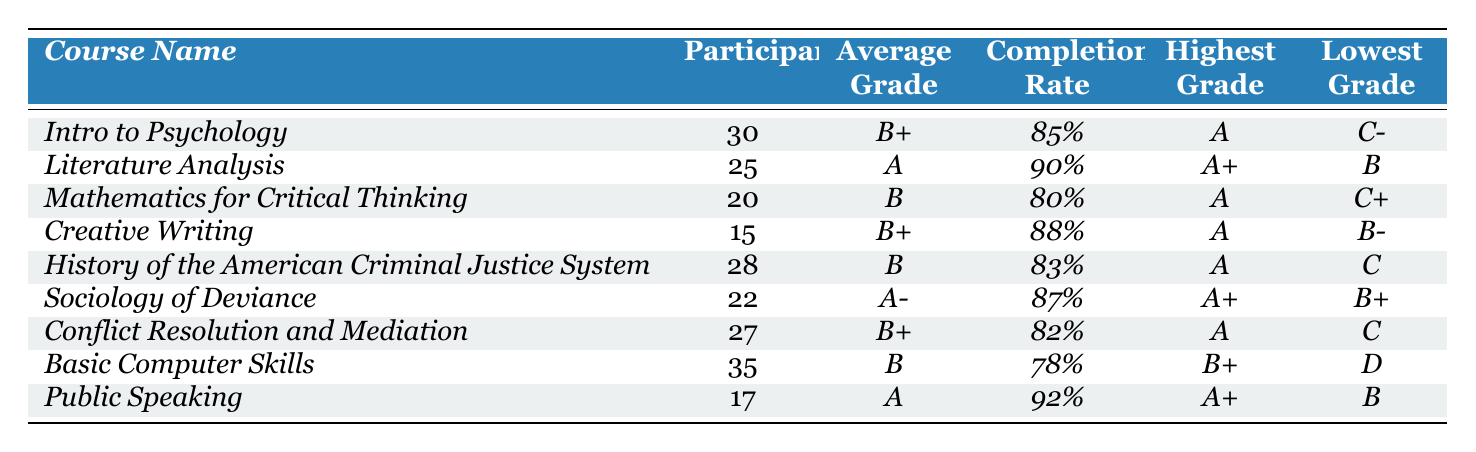What is the highest grade received in the _Literature Analysis_ course? The highest grade for the _Literature Analysis_ course is indicated in the table as _A+_.
Answer: _A+_ How many participants were there in total for all courses combined? To find the total number of participants, I sum the participants from each course: 30 + 25 + 20 + 15 + 28 + 22 + 27 + 35 + 17 = 249.
Answer: 249 What was the completion rate for the _Basic Computer Skills_ course? The completion rate for the _Basic Computer Skills_ course, as shown in the table, is _78%_.
Answer: _78%_ Which course had the lowest average grade? By comparing the average grades, the _Mathematics for Critical Thinking_ course has the lowest average grade of _B_.
Answer: _B_ Is the completion rate for _Public Speaking_ higher than that for _Sociology of Deviance_? The completion rates are _92%_ for _Public Speaking_ and _87%_ for _Sociology of Deviance_. Since 92% is greater than 87%, the answer is yes.
Answer: Yes What grade is achieved by the maximum number of participants? The maximum number of participants is in the _Basic Computer Skills_ course with 35 participants, and the average grade is _B_.
Answer: _B_ How many courses had an average grade higher than _B+_? The courses with an average grade higher than _B+_ are _Literature Analysis_ (A), and _Sociology of Deviance_ (A-). Therefore, there are 2 such courses.
Answer: 2 What is the difference between the highest and lowest completion rates? The highest completion rate is 92% from _Public Speaking_ and the lowest is 78% from _Basic Computer Skills_. The difference is 92% - 78% = 14%.
Answer: 14% Which course had the highest number of participants and what was its average grade? The course with the highest number of participants is _Basic Computer Skills_, which had 35 participants and an average grade of _B_.
Answer: _B_ If we consider the average grades, how many courses had below an average grade of _B+_? The courses below an average grade of _B+_ are _Mathematics for Critical Thinking_ (B), _History of the American Criminal Justice System_ (B), and _Basic Computer Skills_ (B). Thus, there are 3 courses.
Answer: 3 